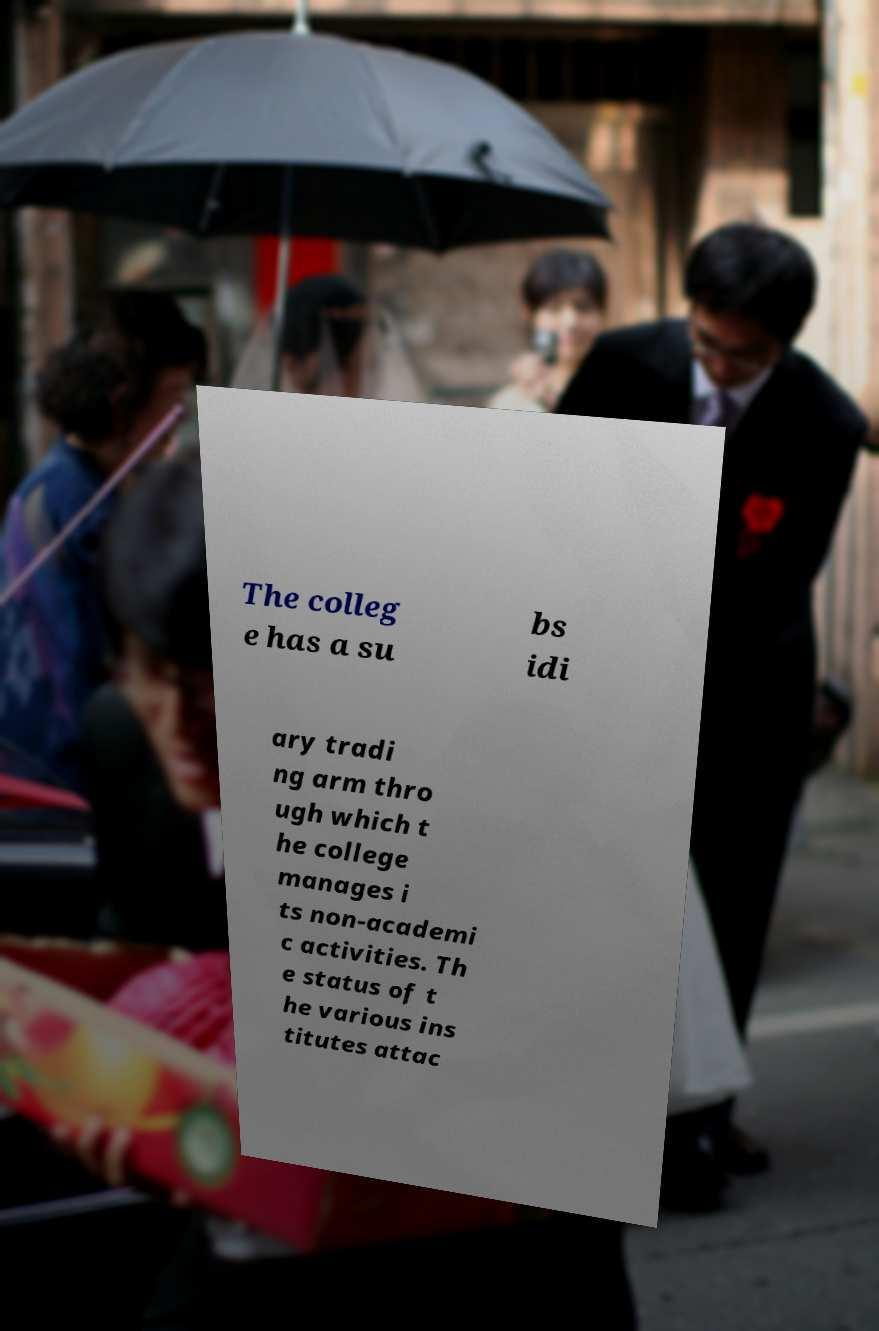Can you read and provide the text displayed in the image?This photo seems to have some interesting text. Can you extract and type it out for me? The colleg e has a su bs idi ary tradi ng arm thro ugh which t he college manages i ts non-academi c activities. Th e status of t he various ins titutes attac 